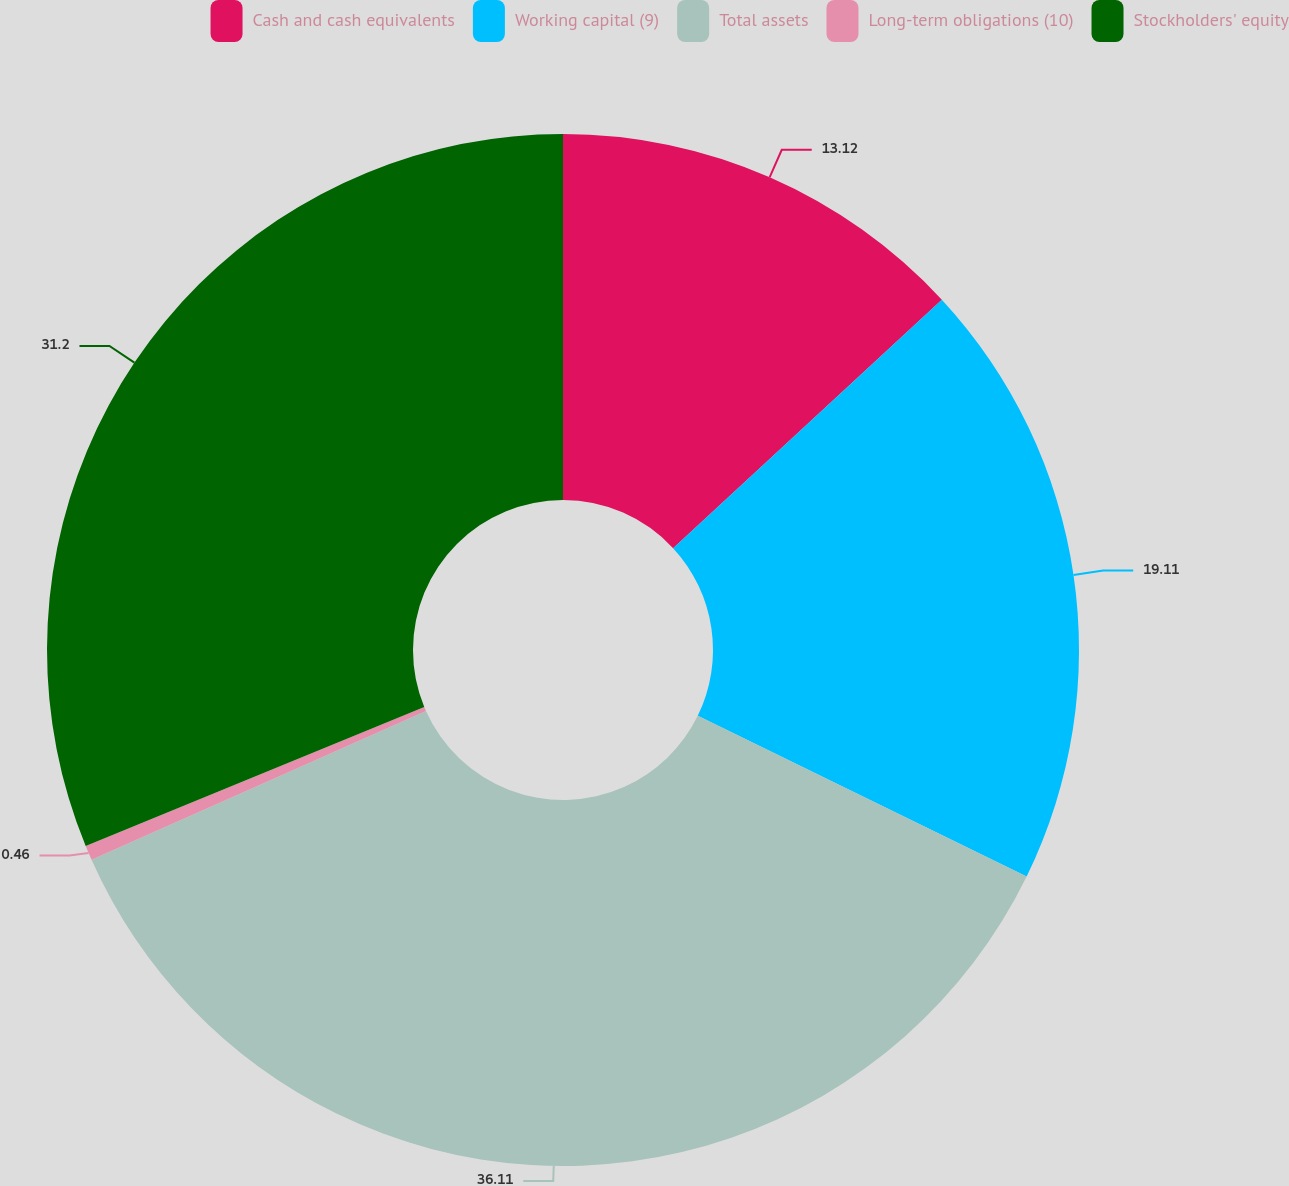Convert chart. <chart><loc_0><loc_0><loc_500><loc_500><pie_chart><fcel>Cash and cash equivalents<fcel>Working capital (9)<fcel>Total assets<fcel>Long-term obligations (10)<fcel>Stockholders' equity<nl><fcel>13.12%<fcel>19.11%<fcel>36.1%<fcel>0.46%<fcel>31.2%<nl></chart> 